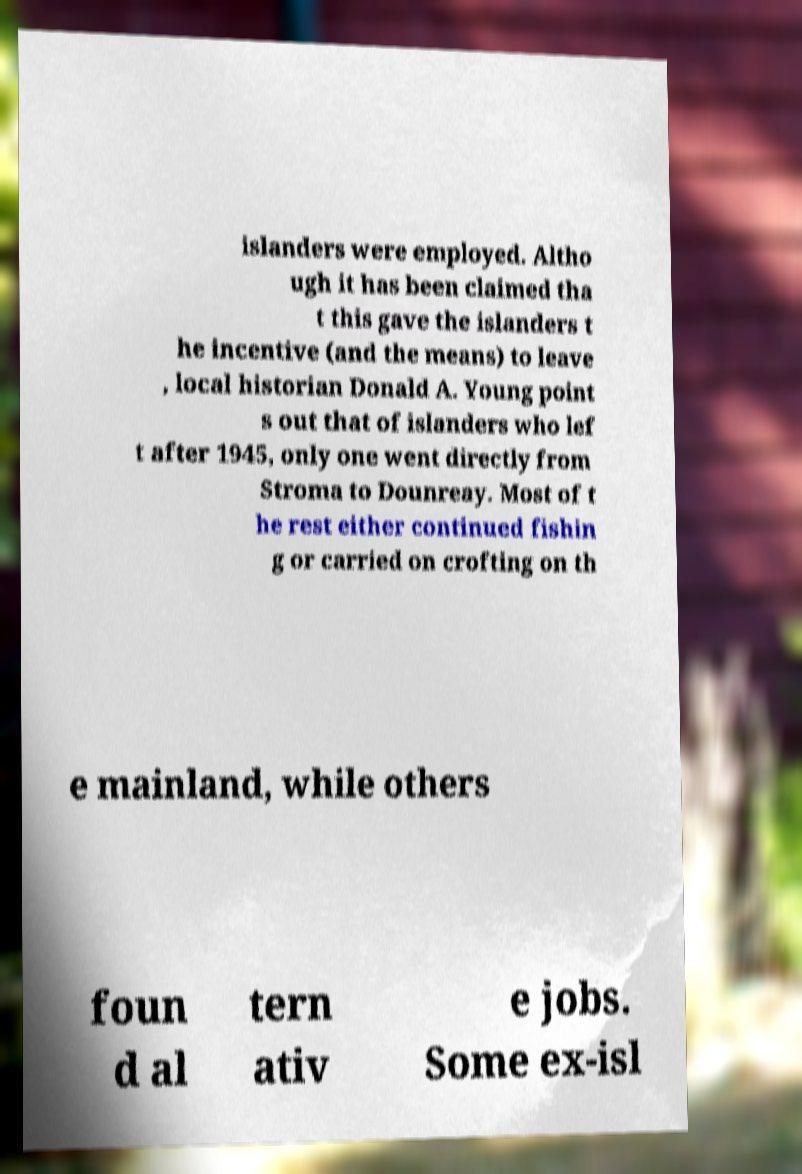There's text embedded in this image that I need extracted. Can you transcribe it verbatim? islanders were employed. Altho ugh it has been claimed tha t this gave the islanders t he incentive (and the means) to leave , local historian Donald A. Young point s out that of islanders who lef t after 1945, only one went directly from Stroma to Dounreay. Most of t he rest either continued fishin g or carried on crofting on th e mainland, while others foun d al tern ativ e jobs. Some ex-isl 